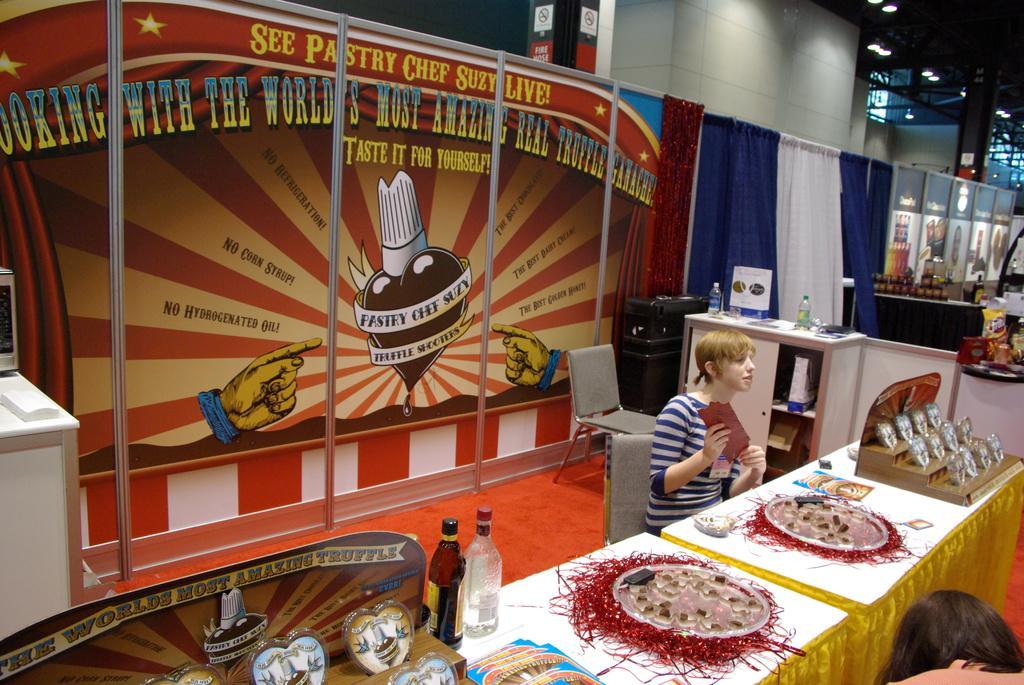How would you summarize this image in a sentence or two? In this image there is a person sitting on chair, in front of person there is table, on that table there are bottles and food items , beside the person there is cupboard in that cupboard there are bottles, in the background there are posters. 